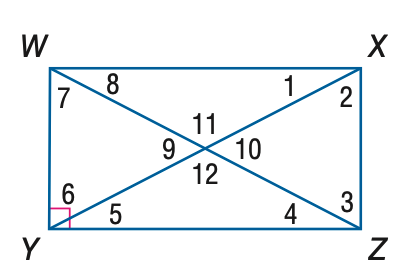Answer the mathemtical geometry problem and directly provide the correct option letter.
Question: Quadrilateral W X Y Z is a rectangle. Find the measure of \angle 8 if m \angle 1 = 30.
Choices: A: 30 B: 60 C: 90 D: 120 A 